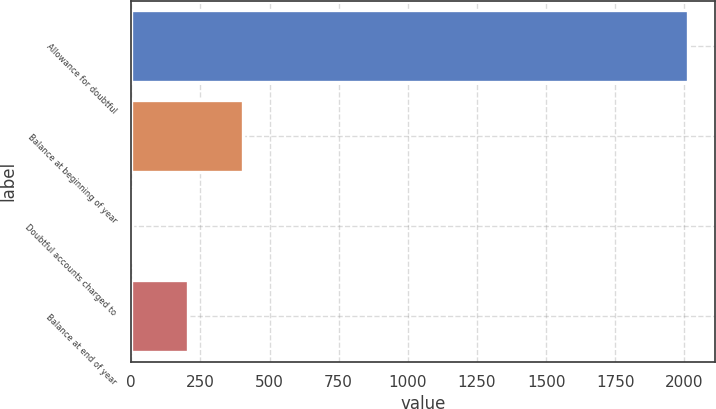Convert chart. <chart><loc_0><loc_0><loc_500><loc_500><bar_chart><fcel>Allowance for doubtful<fcel>Balance at beginning of year<fcel>Doubtful accounts charged to<fcel>Balance at end of year<nl><fcel>2012<fcel>404.8<fcel>3<fcel>203.9<nl></chart> 